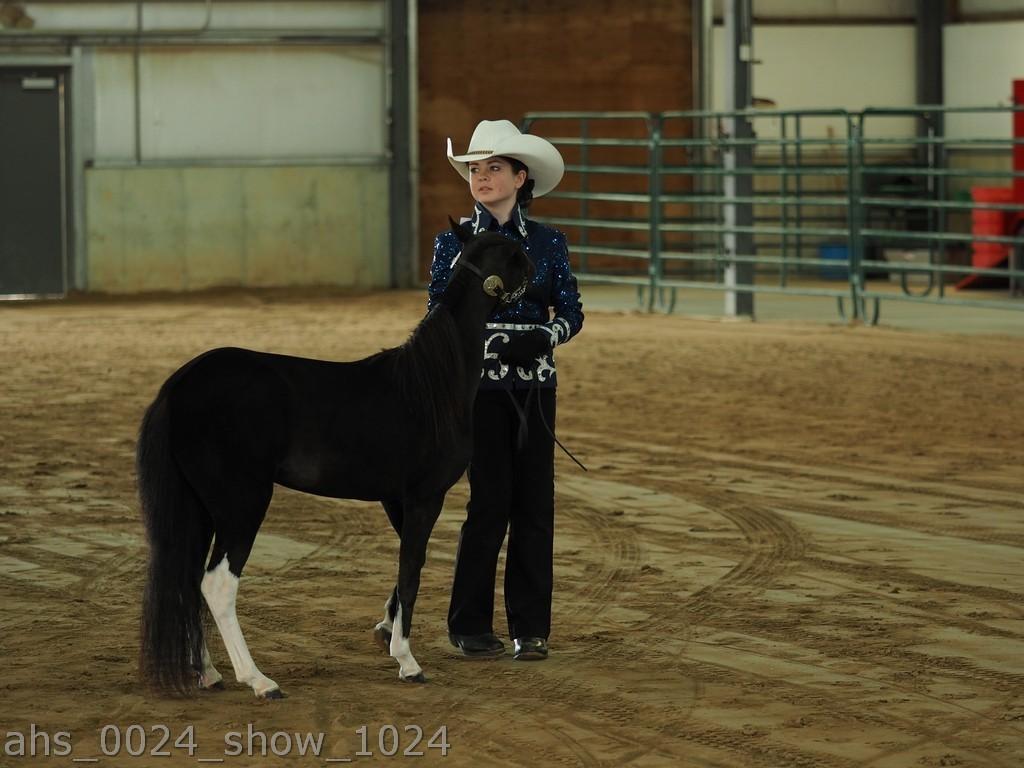Please provide a concise description of this image. In the picture I can see a woman is standing on the ground and wearing a white color hat. I can also see an animal is standing on the ground. In the background I can see fence, wall and some other objects. On the bottom left side of the image I can see a watermark. 